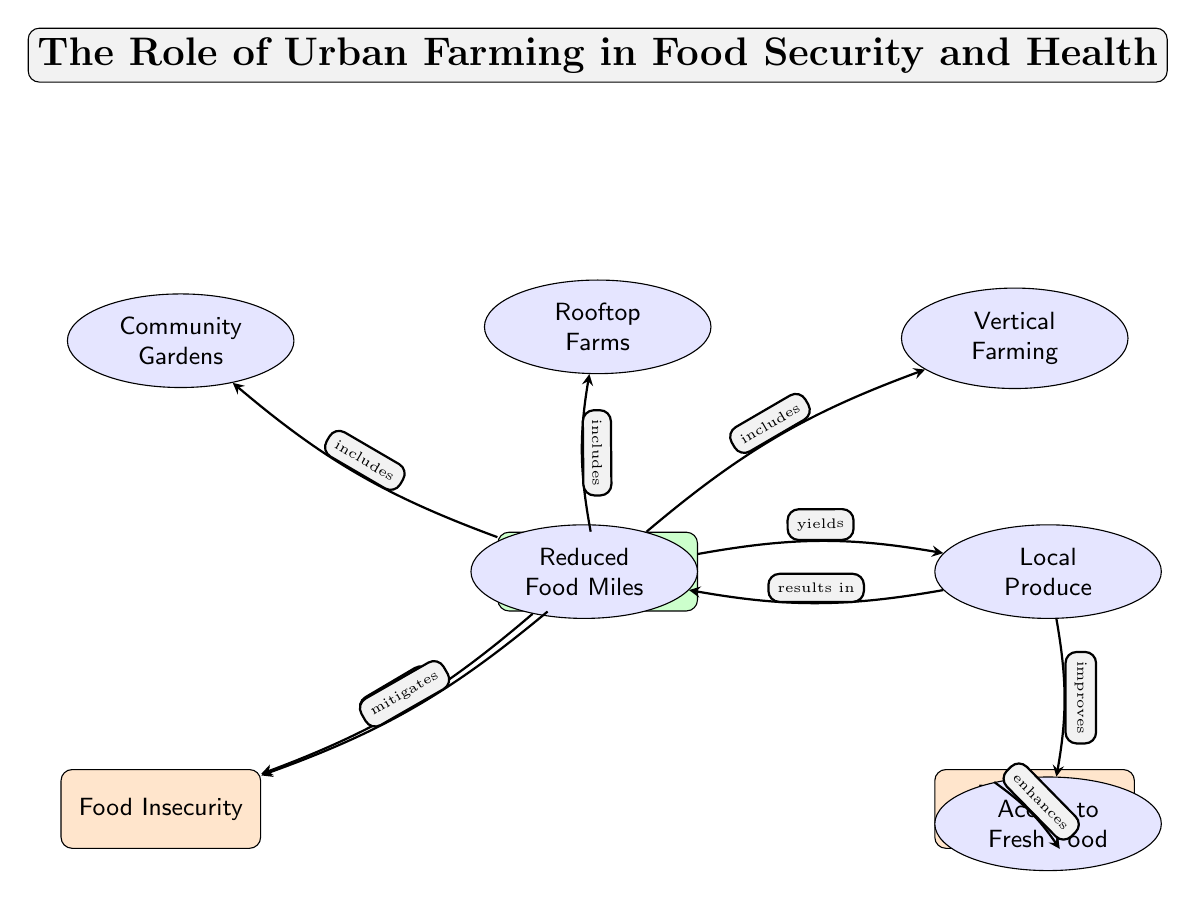What is the main focus of the diagram? The title at the top of the diagram states "The Role of Urban Farming in Food Security and Health," indicating that its primary focus is on how urban farming relates to food security and nutritional health.
Answer: Urban Farming How many types of urban farming are mentioned in the diagram? The diagram lists three types of urban farming: Community Gardens, Rooftop Farms, and Vertical Farming. Therefore, the total count of types is three.
Answer: Three Which node directly connects to "Nutritional Health"? The arrow labeled "enhances" indicates that the node "Access to Fresh Food" connects directly to the node "Nutritional Health."
Answer: Access to Fresh Food What effect does "Urban Farming" have on "Food Insecurity"? The diagram specifies that "Urban Farming" not only includes food-related initiatives but also explicitly states it "mitigates" "Food Insecurity." Therefore, the effect is direct mitigation.
Answer: Mitigates Which node results in "Reduced Food Miles"? The node "Local Produce" has a direct arrow pointing to "Reduced Food Miles," marked as "results in." Thus, the node that leads to reduced food miles is "Local Produce."
Answer: Local Produce How does "Access to Fresh Food" influence "Nutritional Health"? Through the diagram, it's shown that "Access to Fresh Food" has an arrow pointing to "Nutritional Health," with the relationship indicated as "enhances," which denotes a positive influence.
Answer: Enhances What are the two outcomes of "Local Produce"? The diagram draws arrows from "Local Produce" to "Access to Fresh Food" and "Reduced Food Miles," showing that both outcomes result from local produce.
Answer: Access to Fresh Food, Reduced Food Miles Which type of urban farming is linked to "Food Insecurity"? The diagram shows an arrow from "Urban Farming" to "Food Insecurity" indicating that urban farming directly affects food insecurity. Therefore, all types of urban farming are linked to it.
Answer: Urban Farming 